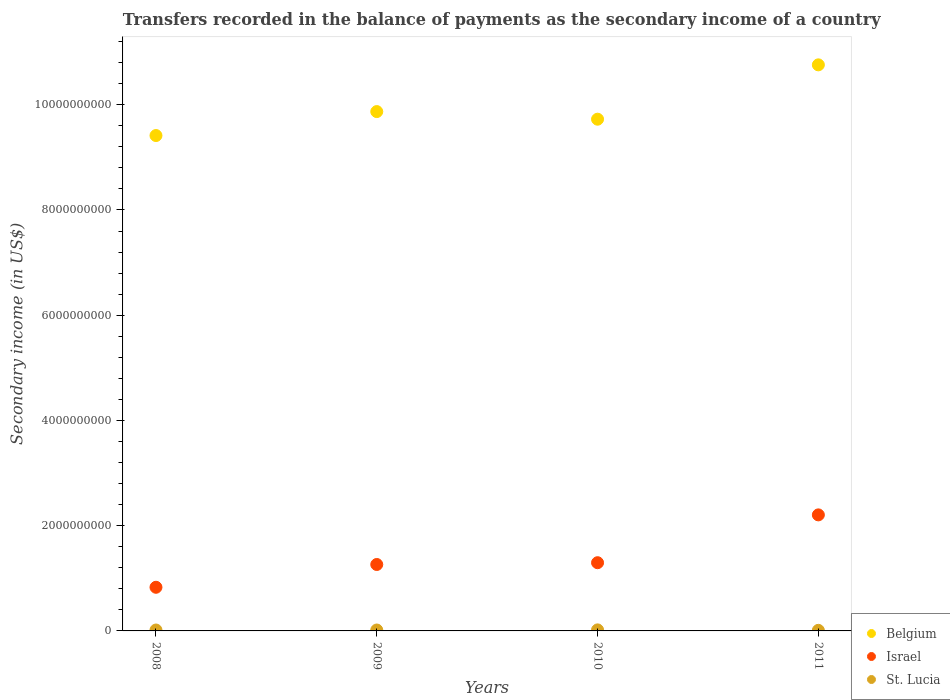How many different coloured dotlines are there?
Offer a very short reply. 3. Is the number of dotlines equal to the number of legend labels?
Give a very brief answer. Yes. What is the secondary income of in Israel in 2009?
Give a very brief answer. 1.26e+09. Across all years, what is the maximum secondary income of in St. Lucia?
Ensure brevity in your answer.  1.96e+07. Across all years, what is the minimum secondary income of in Israel?
Ensure brevity in your answer.  8.30e+08. What is the total secondary income of in St. Lucia in the graph?
Your response must be concise. 6.55e+07. What is the difference between the secondary income of in Israel in 2009 and that in 2011?
Ensure brevity in your answer.  -9.43e+08. What is the difference between the secondary income of in Israel in 2011 and the secondary income of in Belgium in 2009?
Offer a terse response. -7.66e+09. What is the average secondary income of in Israel per year?
Keep it short and to the point. 1.40e+09. In the year 2010, what is the difference between the secondary income of in Belgium and secondary income of in St. Lucia?
Keep it short and to the point. 9.71e+09. What is the ratio of the secondary income of in Israel in 2010 to that in 2011?
Ensure brevity in your answer.  0.59. What is the difference between the highest and the second highest secondary income of in Belgium?
Your answer should be very brief. 8.88e+08. What is the difference between the highest and the lowest secondary income of in Belgium?
Make the answer very short. 1.34e+09. Is it the case that in every year, the sum of the secondary income of in Israel and secondary income of in Belgium  is greater than the secondary income of in St. Lucia?
Provide a succinct answer. Yes. How many dotlines are there?
Offer a terse response. 3. How many years are there in the graph?
Ensure brevity in your answer.  4. What is the difference between two consecutive major ticks on the Y-axis?
Provide a short and direct response. 2.00e+09. Are the values on the major ticks of Y-axis written in scientific E-notation?
Your answer should be compact. No. What is the title of the graph?
Ensure brevity in your answer.  Transfers recorded in the balance of payments as the secondary income of a country. Does "Monaco" appear as one of the legend labels in the graph?
Offer a terse response. No. What is the label or title of the Y-axis?
Provide a succinct answer. Secondary income (in US$). What is the Secondary income (in US$) of Belgium in 2008?
Make the answer very short. 9.41e+09. What is the Secondary income (in US$) of Israel in 2008?
Provide a succinct answer. 8.30e+08. What is the Secondary income (in US$) of St. Lucia in 2008?
Offer a very short reply. 1.73e+07. What is the Secondary income (in US$) in Belgium in 2009?
Provide a succinct answer. 9.87e+09. What is the Secondary income (in US$) of Israel in 2009?
Offer a terse response. 1.26e+09. What is the Secondary income (in US$) of St. Lucia in 2009?
Offer a very short reply. 1.74e+07. What is the Secondary income (in US$) in Belgium in 2010?
Make the answer very short. 9.72e+09. What is the Secondary income (in US$) in Israel in 2010?
Ensure brevity in your answer.  1.30e+09. What is the Secondary income (in US$) in St. Lucia in 2010?
Provide a short and direct response. 1.96e+07. What is the Secondary income (in US$) in Belgium in 2011?
Offer a very short reply. 1.08e+1. What is the Secondary income (in US$) of Israel in 2011?
Provide a short and direct response. 2.21e+09. What is the Secondary income (in US$) in St. Lucia in 2011?
Your answer should be very brief. 1.12e+07. Across all years, what is the maximum Secondary income (in US$) in Belgium?
Your answer should be very brief. 1.08e+1. Across all years, what is the maximum Secondary income (in US$) of Israel?
Your answer should be compact. 2.21e+09. Across all years, what is the maximum Secondary income (in US$) in St. Lucia?
Offer a very short reply. 1.96e+07. Across all years, what is the minimum Secondary income (in US$) of Belgium?
Give a very brief answer. 9.41e+09. Across all years, what is the minimum Secondary income (in US$) in Israel?
Make the answer very short. 8.30e+08. Across all years, what is the minimum Secondary income (in US$) in St. Lucia?
Your response must be concise. 1.12e+07. What is the total Secondary income (in US$) in Belgium in the graph?
Offer a very short reply. 3.98e+1. What is the total Secondary income (in US$) in Israel in the graph?
Make the answer very short. 5.59e+09. What is the total Secondary income (in US$) of St. Lucia in the graph?
Your answer should be compact. 6.55e+07. What is the difference between the Secondary income (in US$) of Belgium in 2008 and that in 2009?
Make the answer very short. -4.55e+08. What is the difference between the Secondary income (in US$) in Israel in 2008 and that in 2009?
Your answer should be compact. -4.33e+08. What is the difference between the Secondary income (in US$) of St. Lucia in 2008 and that in 2009?
Offer a terse response. -1.74e+05. What is the difference between the Secondary income (in US$) in Belgium in 2008 and that in 2010?
Your answer should be very brief. -3.11e+08. What is the difference between the Secondary income (in US$) in Israel in 2008 and that in 2010?
Your answer should be compact. -4.67e+08. What is the difference between the Secondary income (in US$) of St. Lucia in 2008 and that in 2010?
Keep it short and to the point. -2.34e+06. What is the difference between the Secondary income (in US$) in Belgium in 2008 and that in 2011?
Provide a succinct answer. -1.34e+09. What is the difference between the Secondary income (in US$) in Israel in 2008 and that in 2011?
Provide a short and direct response. -1.38e+09. What is the difference between the Secondary income (in US$) in St. Lucia in 2008 and that in 2011?
Your answer should be compact. 6.05e+06. What is the difference between the Secondary income (in US$) in Belgium in 2009 and that in 2010?
Give a very brief answer. 1.45e+08. What is the difference between the Secondary income (in US$) of Israel in 2009 and that in 2010?
Keep it short and to the point. -3.38e+07. What is the difference between the Secondary income (in US$) in St. Lucia in 2009 and that in 2010?
Give a very brief answer. -2.16e+06. What is the difference between the Secondary income (in US$) of Belgium in 2009 and that in 2011?
Provide a succinct answer. -8.88e+08. What is the difference between the Secondary income (in US$) of Israel in 2009 and that in 2011?
Provide a succinct answer. -9.43e+08. What is the difference between the Secondary income (in US$) in St. Lucia in 2009 and that in 2011?
Give a very brief answer. 6.22e+06. What is the difference between the Secondary income (in US$) of Belgium in 2010 and that in 2011?
Your response must be concise. -1.03e+09. What is the difference between the Secondary income (in US$) of Israel in 2010 and that in 2011?
Offer a very short reply. -9.09e+08. What is the difference between the Secondary income (in US$) in St. Lucia in 2010 and that in 2011?
Offer a terse response. 8.38e+06. What is the difference between the Secondary income (in US$) in Belgium in 2008 and the Secondary income (in US$) in Israel in 2009?
Offer a terse response. 8.15e+09. What is the difference between the Secondary income (in US$) in Belgium in 2008 and the Secondary income (in US$) in St. Lucia in 2009?
Make the answer very short. 9.40e+09. What is the difference between the Secondary income (in US$) of Israel in 2008 and the Secondary income (in US$) of St. Lucia in 2009?
Keep it short and to the point. 8.12e+08. What is the difference between the Secondary income (in US$) of Belgium in 2008 and the Secondary income (in US$) of Israel in 2010?
Your answer should be compact. 8.12e+09. What is the difference between the Secondary income (in US$) of Belgium in 2008 and the Secondary income (in US$) of St. Lucia in 2010?
Ensure brevity in your answer.  9.39e+09. What is the difference between the Secondary income (in US$) in Israel in 2008 and the Secondary income (in US$) in St. Lucia in 2010?
Give a very brief answer. 8.10e+08. What is the difference between the Secondary income (in US$) of Belgium in 2008 and the Secondary income (in US$) of Israel in 2011?
Ensure brevity in your answer.  7.21e+09. What is the difference between the Secondary income (in US$) in Belgium in 2008 and the Secondary income (in US$) in St. Lucia in 2011?
Offer a terse response. 9.40e+09. What is the difference between the Secondary income (in US$) in Israel in 2008 and the Secondary income (in US$) in St. Lucia in 2011?
Make the answer very short. 8.18e+08. What is the difference between the Secondary income (in US$) of Belgium in 2009 and the Secondary income (in US$) of Israel in 2010?
Make the answer very short. 8.57e+09. What is the difference between the Secondary income (in US$) in Belgium in 2009 and the Secondary income (in US$) in St. Lucia in 2010?
Your response must be concise. 9.85e+09. What is the difference between the Secondary income (in US$) of Israel in 2009 and the Secondary income (in US$) of St. Lucia in 2010?
Offer a terse response. 1.24e+09. What is the difference between the Secondary income (in US$) of Belgium in 2009 and the Secondary income (in US$) of Israel in 2011?
Provide a succinct answer. 7.66e+09. What is the difference between the Secondary income (in US$) of Belgium in 2009 and the Secondary income (in US$) of St. Lucia in 2011?
Provide a succinct answer. 9.86e+09. What is the difference between the Secondary income (in US$) of Israel in 2009 and the Secondary income (in US$) of St. Lucia in 2011?
Provide a short and direct response. 1.25e+09. What is the difference between the Secondary income (in US$) in Belgium in 2010 and the Secondary income (in US$) in Israel in 2011?
Provide a succinct answer. 7.52e+09. What is the difference between the Secondary income (in US$) of Belgium in 2010 and the Secondary income (in US$) of St. Lucia in 2011?
Provide a succinct answer. 9.71e+09. What is the difference between the Secondary income (in US$) in Israel in 2010 and the Secondary income (in US$) in St. Lucia in 2011?
Give a very brief answer. 1.29e+09. What is the average Secondary income (in US$) in Belgium per year?
Provide a succinct answer. 9.94e+09. What is the average Secondary income (in US$) of Israel per year?
Provide a succinct answer. 1.40e+09. What is the average Secondary income (in US$) of St. Lucia per year?
Give a very brief answer. 1.64e+07. In the year 2008, what is the difference between the Secondary income (in US$) in Belgium and Secondary income (in US$) in Israel?
Provide a succinct answer. 8.58e+09. In the year 2008, what is the difference between the Secondary income (in US$) in Belgium and Secondary income (in US$) in St. Lucia?
Provide a succinct answer. 9.40e+09. In the year 2008, what is the difference between the Secondary income (in US$) in Israel and Secondary income (in US$) in St. Lucia?
Keep it short and to the point. 8.12e+08. In the year 2009, what is the difference between the Secondary income (in US$) of Belgium and Secondary income (in US$) of Israel?
Your answer should be compact. 8.61e+09. In the year 2009, what is the difference between the Secondary income (in US$) of Belgium and Secondary income (in US$) of St. Lucia?
Ensure brevity in your answer.  9.85e+09. In the year 2009, what is the difference between the Secondary income (in US$) of Israel and Secondary income (in US$) of St. Lucia?
Make the answer very short. 1.25e+09. In the year 2010, what is the difference between the Secondary income (in US$) in Belgium and Secondary income (in US$) in Israel?
Offer a terse response. 8.43e+09. In the year 2010, what is the difference between the Secondary income (in US$) of Belgium and Secondary income (in US$) of St. Lucia?
Provide a short and direct response. 9.71e+09. In the year 2010, what is the difference between the Secondary income (in US$) of Israel and Secondary income (in US$) of St. Lucia?
Provide a succinct answer. 1.28e+09. In the year 2011, what is the difference between the Secondary income (in US$) in Belgium and Secondary income (in US$) in Israel?
Your response must be concise. 8.55e+09. In the year 2011, what is the difference between the Secondary income (in US$) of Belgium and Secondary income (in US$) of St. Lucia?
Keep it short and to the point. 1.07e+1. In the year 2011, what is the difference between the Secondary income (in US$) in Israel and Secondary income (in US$) in St. Lucia?
Ensure brevity in your answer.  2.19e+09. What is the ratio of the Secondary income (in US$) of Belgium in 2008 to that in 2009?
Your answer should be compact. 0.95. What is the ratio of the Secondary income (in US$) of Israel in 2008 to that in 2009?
Provide a short and direct response. 0.66. What is the ratio of the Secondary income (in US$) of Belgium in 2008 to that in 2010?
Ensure brevity in your answer.  0.97. What is the ratio of the Secondary income (in US$) in Israel in 2008 to that in 2010?
Ensure brevity in your answer.  0.64. What is the ratio of the Secondary income (in US$) of St. Lucia in 2008 to that in 2010?
Provide a succinct answer. 0.88. What is the ratio of the Secondary income (in US$) of Belgium in 2008 to that in 2011?
Make the answer very short. 0.88. What is the ratio of the Secondary income (in US$) of Israel in 2008 to that in 2011?
Provide a succinct answer. 0.38. What is the ratio of the Secondary income (in US$) in St. Lucia in 2008 to that in 2011?
Keep it short and to the point. 1.54. What is the ratio of the Secondary income (in US$) in Belgium in 2009 to that in 2010?
Provide a short and direct response. 1.01. What is the ratio of the Secondary income (in US$) in Israel in 2009 to that in 2010?
Ensure brevity in your answer.  0.97. What is the ratio of the Secondary income (in US$) of St. Lucia in 2009 to that in 2010?
Give a very brief answer. 0.89. What is the ratio of the Secondary income (in US$) of Belgium in 2009 to that in 2011?
Your answer should be compact. 0.92. What is the ratio of the Secondary income (in US$) of Israel in 2009 to that in 2011?
Your response must be concise. 0.57. What is the ratio of the Secondary income (in US$) of St. Lucia in 2009 to that in 2011?
Provide a short and direct response. 1.55. What is the ratio of the Secondary income (in US$) of Belgium in 2010 to that in 2011?
Offer a very short reply. 0.9. What is the ratio of the Secondary income (in US$) of Israel in 2010 to that in 2011?
Your response must be concise. 0.59. What is the ratio of the Secondary income (in US$) in St. Lucia in 2010 to that in 2011?
Offer a terse response. 1.75. What is the difference between the highest and the second highest Secondary income (in US$) of Belgium?
Keep it short and to the point. 8.88e+08. What is the difference between the highest and the second highest Secondary income (in US$) in Israel?
Offer a terse response. 9.09e+08. What is the difference between the highest and the second highest Secondary income (in US$) of St. Lucia?
Your answer should be very brief. 2.16e+06. What is the difference between the highest and the lowest Secondary income (in US$) of Belgium?
Your answer should be very brief. 1.34e+09. What is the difference between the highest and the lowest Secondary income (in US$) in Israel?
Your answer should be very brief. 1.38e+09. What is the difference between the highest and the lowest Secondary income (in US$) in St. Lucia?
Give a very brief answer. 8.38e+06. 